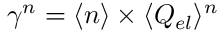<formula> <loc_0><loc_0><loc_500><loc_500>\gamma ^ { n } = \langle n \rangle \times \langle Q _ { e l } \rangle ^ { n }</formula> 